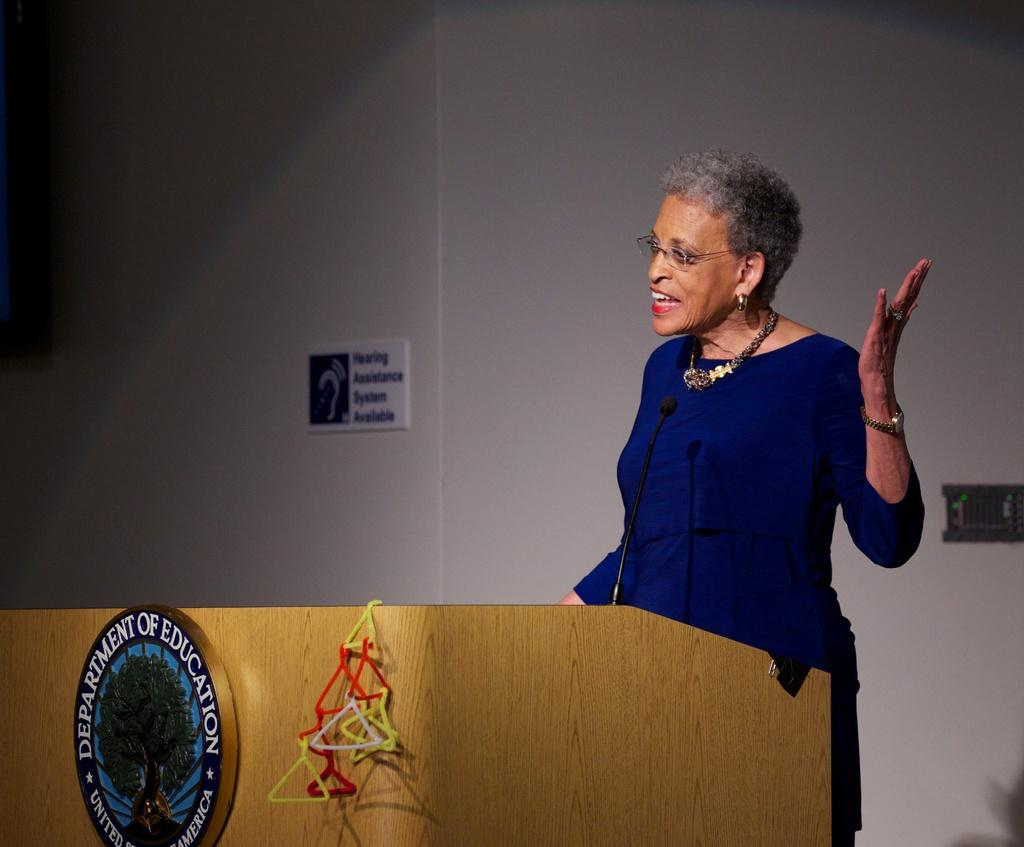Who is present in the image? There is a person in the image. What is the person wearing? The person is wearing clothes. What is the person standing in front of? The person is standing in front of a podium. What can be seen in the middle of the image? There is a board in the middle of the image. What is visible in the background of the image? There is a wall in the background of the image. What type of zinc is present on the board in the image? There is no zinc present on the board in the image. How does the person's desire to speak affect the image? The image does not provide any information about the person's desires or intentions, so it cannot be determined how their desire to speak might affect the image. 